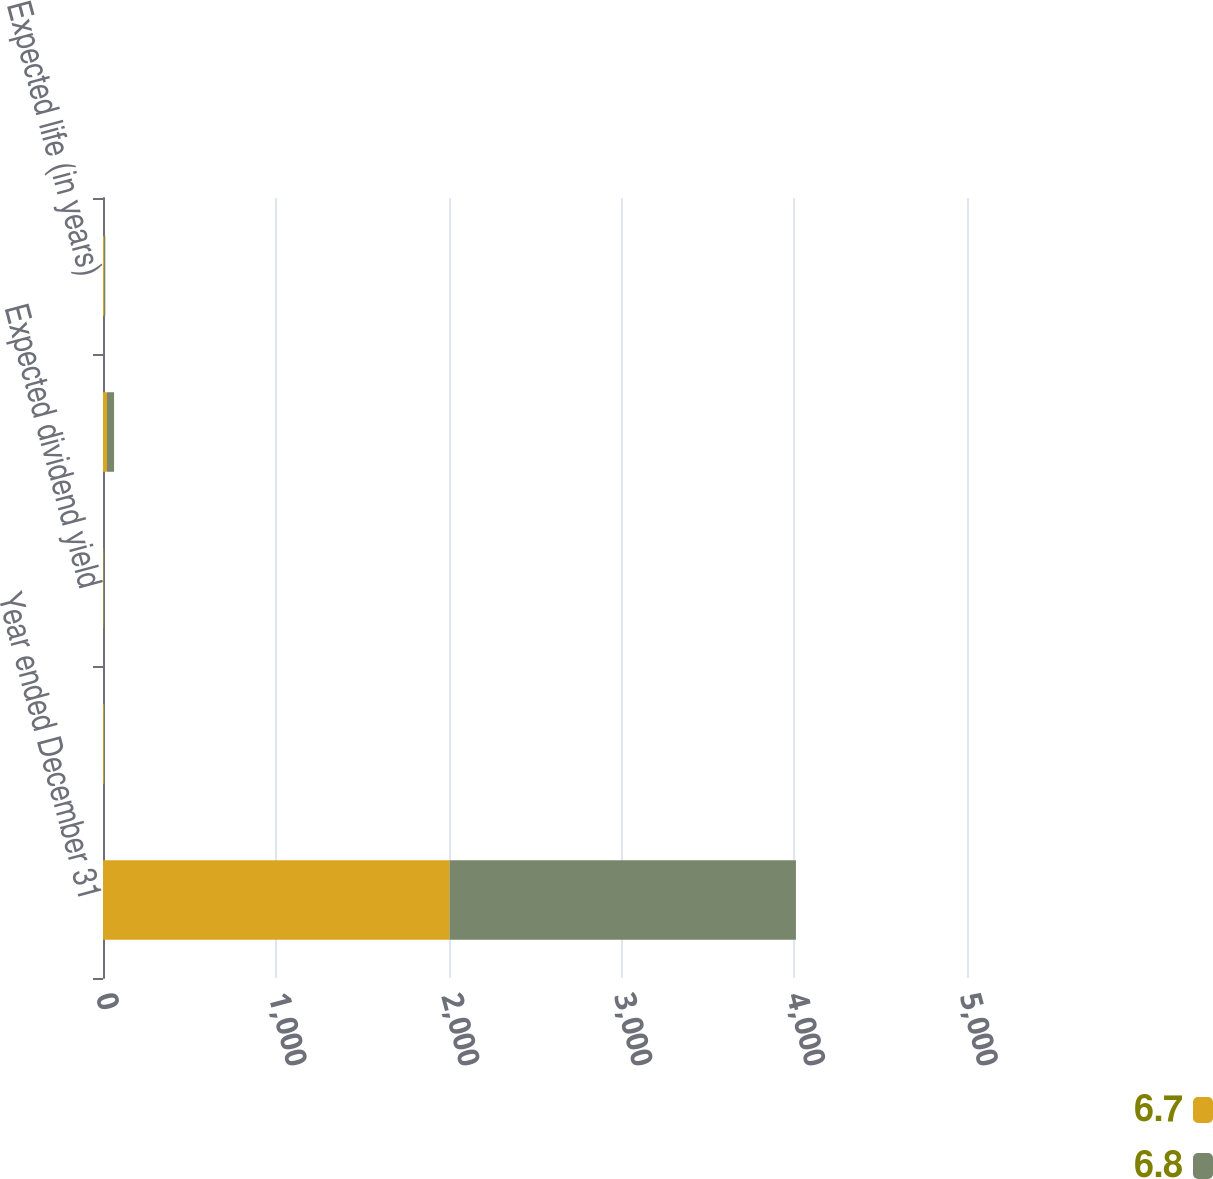<chart> <loc_0><loc_0><loc_500><loc_500><stacked_bar_chart><ecel><fcel>Year ended December 31<fcel>Risk-free interest rate<fcel>Expected dividend yield<fcel>Expected common stock price<fcel>Expected life (in years)<nl><fcel>6.7<fcel>2006<fcel>5.11<fcel>2.89<fcel>23<fcel>6.8<nl><fcel>6.8<fcel>2004<fcel>3.44<fcel>3.59<fcel>41<fcel>6.7<nl></chart> 